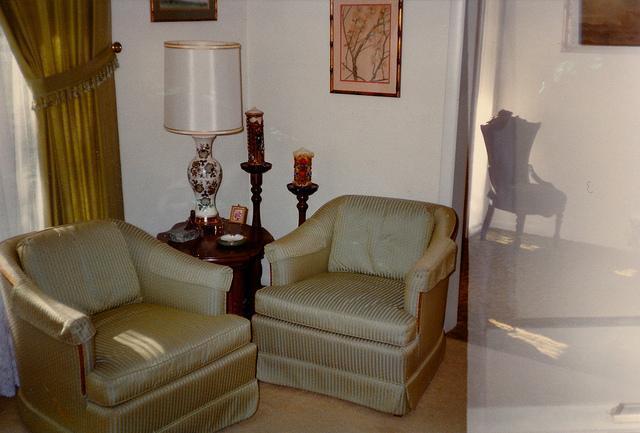How many chairs are there?
Give a very brief answer. 3. How many chairs are in the photo?
Give a very brief answer. 3. How many couches can be seen?
Give a very brief answer. 2. How many boys are walking a white dog?
Give a very brief answer. 0. 